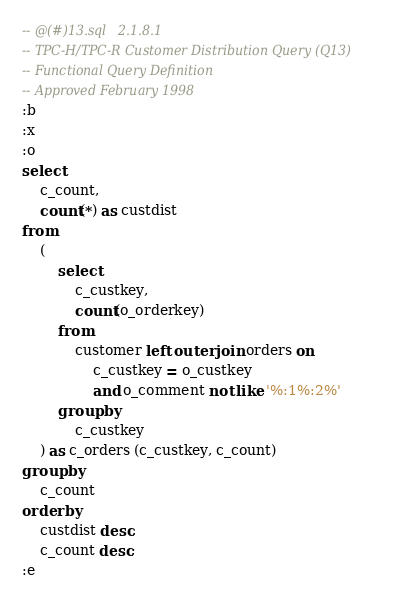Convert code to text. <code><loc_0><loc_0><loc_500><loc_500><_SQL_>-- @(#)13.sql	2.1.8.1
-- TPC-H/TPC-R Customer Distribution Query (Q13)
-- Functional Query Definition
-- Approved February 1998
:b
:x
:o
select
	c_count,
	count(*) as custdist
from
	(
		select
			c_custkey,
			count(o_orderkey)
		from
			customer left outer join orders on
				c_custkey = o_custkey
				and o_comment not like '%:1%:2%'
		group by
			c_custkey
	) as c_orders (c_custkey, c_count)
group by
	c_count
order by
	custdist desc,
	c_count desc;
:e
</code> 